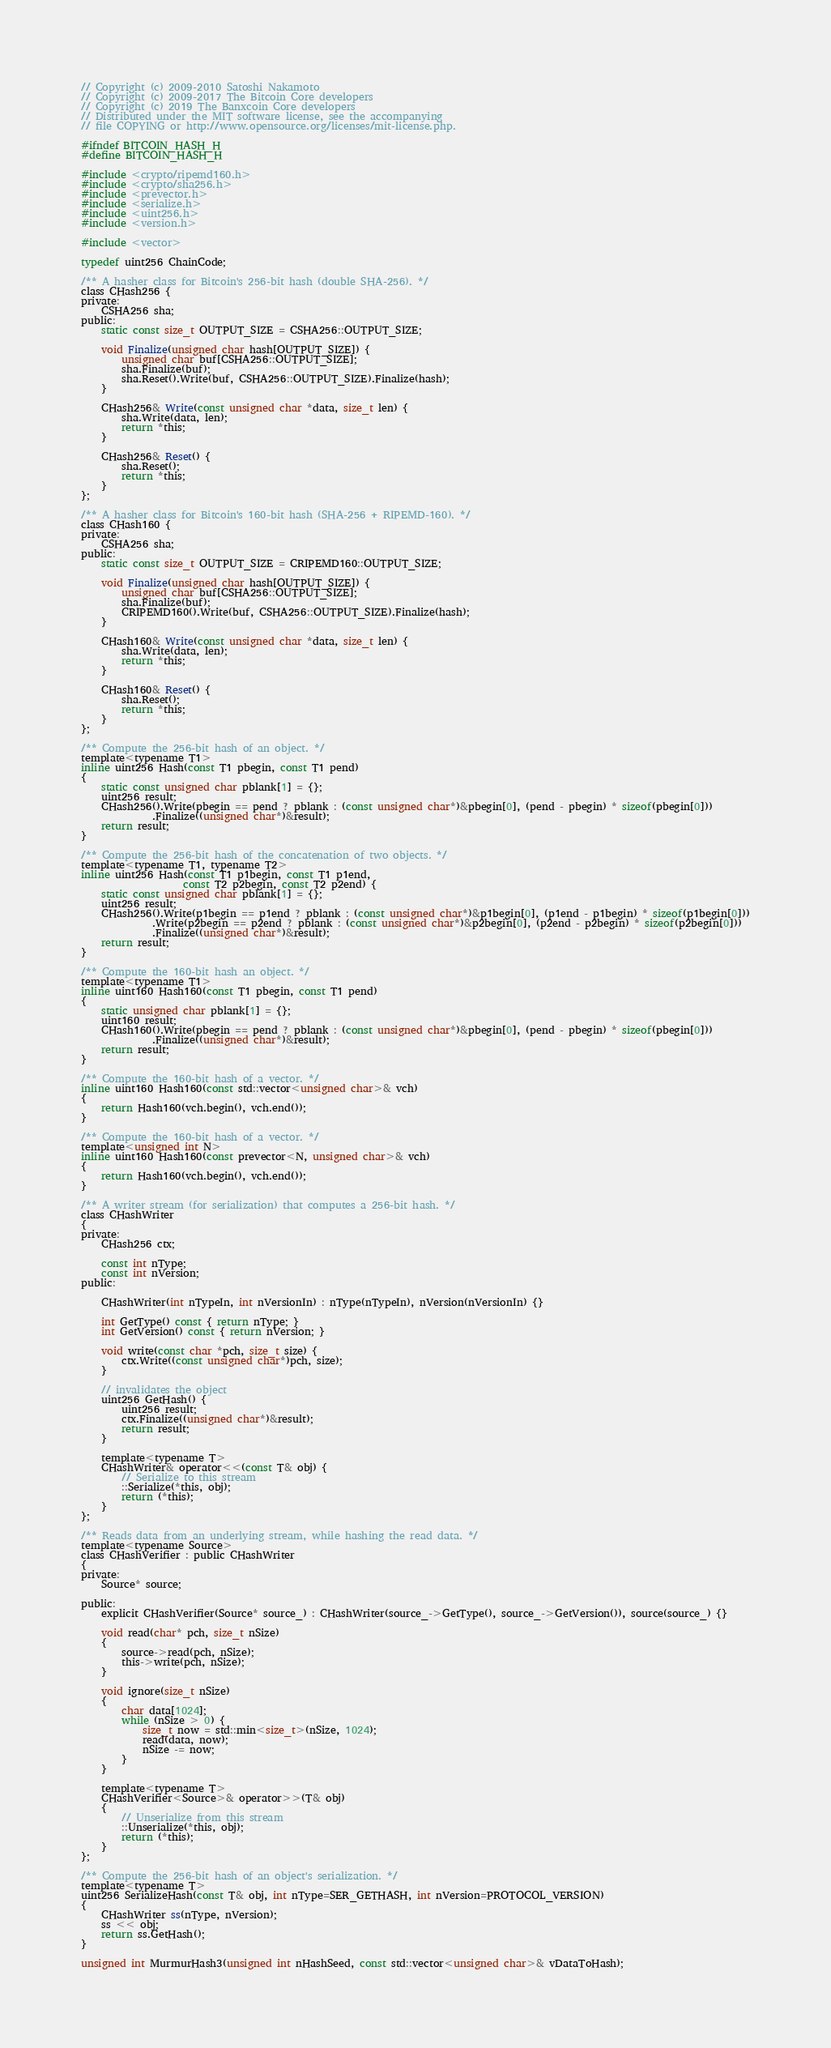<code> <loc_0><loc_0><loc_500><loc_500><_C_>// Copyright (c) 2009-2010 Satoshi Nakamoto
// Copyright (c) 2009-2017 The Bitcoin Core developers
// Copyright (c) 2019 The Banxcoin Core developers
// Distributed under the MIT software license, see the accompanying
// file COPYING or http://www.opensource.org/licenses/mit-license.php.

#ifndef BITCOIN_HASH_H
#define BITCOIN_HASH_H

#include <crypto/ripemd160.h>
#include <crypto/sha256.h>
#include <prevector.h>
#include <serialize.h>
#include <uint256.h>
#include <version.h>

#include <vector>

typedef uint256 ChainCode;

/** A hasher class for Bitcoin's 256-bit hash (double SHA-256). */
class CHash256 {
private:
    CSHA256 sha;
public:
    static const size_t OUTPUT_SIZE = CSHA256::OUTPUT_SIZE;

    void Finalize(unsigned char hash[OUTPUT_SIZE]) {
        unsigned char buf[CSHA256::OUTPUT_SIZE];
        sha.Finalize(buf);
        sha.Reset().Write(buf, CSHA256::OUTPUT_SIZE).Finalize(hash);
    }

    CHash256& Write(const unsigned char *data, size_t len) {
        sha.Write(data, len);
        return *this;
    }

    CHash256& Reset() {
        sha.Reset();
        return *this;
    }
};

/** A hasher class for Bitcoin's 160-bit hash (SHA-256 + RIPEMD-160). */
class CHash160 {
private:
    CSHA256 sha;
public:
    static const size_t OUTPUT_SIZE = CRIPEMD160::OUTPUT_SIZE;

    void Finalize(unsigned char hash[OUTPUT_SIZE]) {
        unsigned char buf[CSHA256::OUTPUT_SIZE];
        sha.Finalize(buf);
        CRIPEMD160().Write(buf, CSHA256::OUTPUT_SIZE).Finalize(hash);
    }

    CHash160& Write(const unsigned char *data, size_t len) {
        sha.Write(data, len);
        return *this;
    }

    CHash160& Reset() {
        sha.Reset();
        return *this;
    }
};

/** Compute the 256-bit hash of an object. */
template<typename T1>
inline uint256 Hash(const T1 pbegin, const T1 pend)
{
    static const unsigned char pblank[1] = {};
    uint256 result;
    CHash256().Write(pbegin == pend ? pblank : (const unsigned char*)&pbegin[0], (pend - pbegin) * sizeof(pbegin[0]))
              .Finalize((unsigned char*)&result);
    return result;
}

/** Compute the 256-bit hash of the concatenation of two objects. */
template<typename T1, typename T2>
inline uint256 Hash(const T1 p1begin, const T1 p1end,
                    const T2 p2begin, const T2 p2end) {
    static const unsigned char pblank[1] = {};
    uint256 result;
    CHash256().Write(p1begin == p1end ? pblank : (const unsigned char*)&p1begin[0], (p1end - p1begin) * sizeof(p1begin[0]))
              .Write(p2begin == p2end ? pblank : (const unsigned char*)&p2begin[0], (p2end - p2begin) * sizeof(p2begin[0]))
              .Finalize((unsigned char*)&result);
    return result;
}

/** Compute the 160-bit hash an object. */
template<typename T1>
inline uint160 Hash160(const T1 pbegin, const T1 pend)
{
    static unsigned char pblank[1] = {};
    uint160 result;
    CHash160().Write(pbegin == pend ? pblank : (const unsigned char*)&pbegin[0], (pend - pbegin) * sizeof(pbegin[0]))
              .Finalize((unsigned char*)&result);
    return result;
}

/** Compute the 160-bit hash of a vector. */
inline uint160 Hash160(const std::vector<unsigned char>& vch)
{
    return Hash160(vch.begin(), vch.end());
}

/** Compute the 160-bit hash of a vector. */
template<unsigned int N>
inline uint160 Hash160(const prevector<N, unsigned char>& vch)
{
    return Hash160(vch.begin(), vch.end());
}

/** A writer stream (for serialization) that computes a 256-bit hash. */
class CHashWriter
{
private:
    CHash256 ctx;

    const int nType;
    const int nVersion;
public:

    CHashWriter(int nTypeIn, int nVersionIn) : nType(nTypeIn), nVersion(nVersionIn) {}

    int GetType() const { return nType; }
    int GetVersion() const { return nVersion; }

    void write(const char *pch, size_t size) {
        ctx.Write((const unsigned char*)pch, size);
    }

    // invalidates the object
    uint256 GetHash() {
        uint256 result;
        ctx.Finalize((unsigned char*)&result);
        return result;
    }

    template<typename T>
    CHashWriter& operator<<(const T& obj) {
        // Serialize to this stream
        ::Serialize(*this, obj);
        return (*this);
    }
};

/** Reads data from an underlying stream, while hashing the read data. */
template<typename Source>
class CHashVerifier : public CHashWriter
{
private:
    Source* source;

public:
    explicit CHashVerifier(Source* source_) : CHashWriter(source_->GetType(), source_->GetVersion()), source(source_) {}

    void read(char* pch, size_t nSize)
    {
        source->read(pch, nSize);
        this->write(pch, nSize);
    }

    void ignore(size_t nSize)
    {
        char data[1024];
        while (nSize > 0) {
            size_t now = std::min<size_t>(nSize, 1024);
            read(data, now);
            nSize -= now;
        }
    }

    template<typename T>
    CHashVerifier<Source>& operator>>(T& obj)
    {
        // Unserialize from this stream
        ::Unserialize(*this, obj);
        return (*this);
    }
};

/** Compute the 256-bit hash of an object's serialization. */
template<typename T>
uint256 SerializeHash(const T& obj, int nType=SER_GETHASH, int nVersion=PROTOCOL_VERSION)
{
    CHashWriter ss(nType, nVersion);
    ss << obj;
    return ss.GetHash();
}

unsigned int MurmurHash3(unsigned int nHashSeed, const std::vector<unsigned char>& vDataToHash);
</code> 